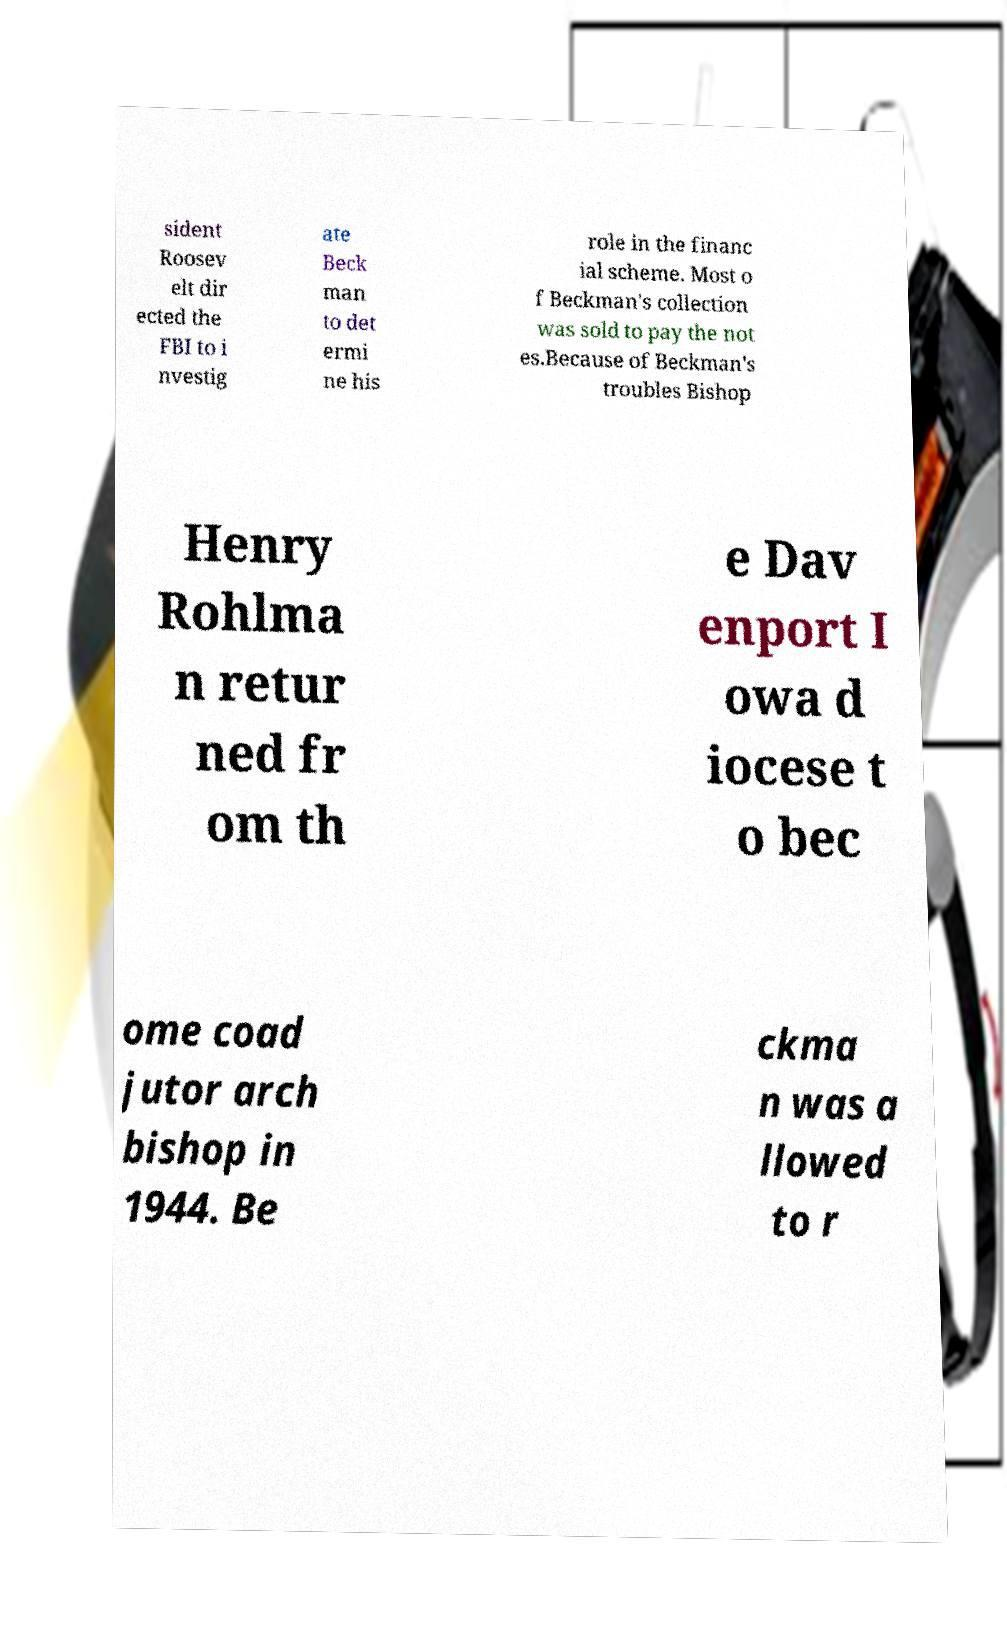Could you extract and type out the text from this image? sident Roosev elt dir ected the FBI to i nvestig ate Beck man to det ermi ne his role in the financ ial scheme. Most o f Beckman's collection was sold to pay the not es.Because of Beckman's troubles Bishop Henry Rohlma n retur ned fr om th e Dav enport I owa d iocese t o bec ome coad jutor arch bishop in 1944. Be ckma n was a llowed to r 